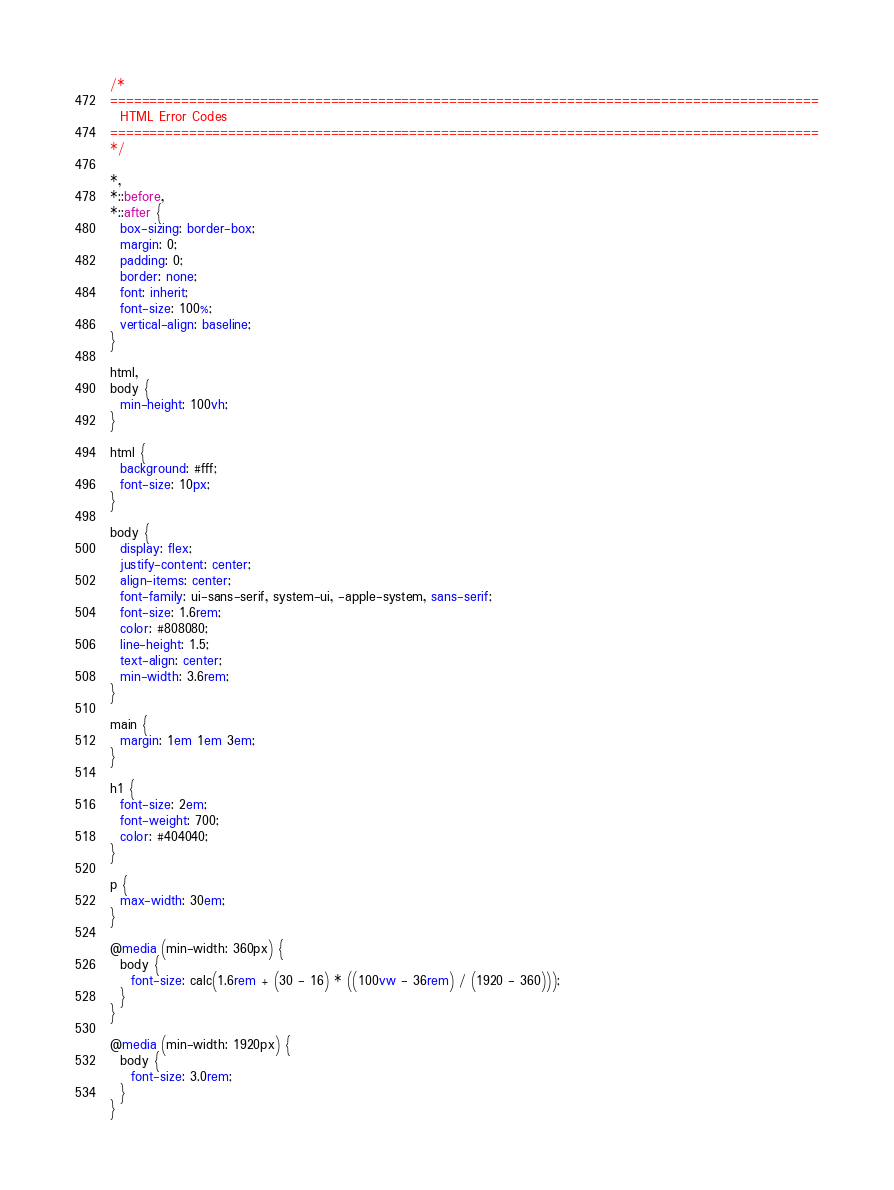<code> <loc_0><loc_0><loc_500><loc_500><_CSS_>/*
==========================================================================================
  HTML Error Codes
==========================================================================================
*/

*,
*::before,
*::after {
  box-sizing: border-box;
  margin: 0;
  padding: 0;
  border: none;
  font: inherit;
  font-size: 100%;
  vertical-align: baseline;
}

html,
body {
  min-height: 100vh;
}

html {
  background: #fff;
  font-size: 10px;
}

body {
  display: flex;
  justify-content: center;
  align-items: center;
  font-family: ui-sans-serif, system-ui, -apple-system, sans-serif;
  font-size: 1.6rem;
  color: #808080;
  line-height: 1.5;
  text-align: center;
  min-width: 3.6rem;
}

main {
  margin: 1em 1em 3em;
}

h1 {
  font-size: 2em;
  font-weight: 700;
  color: #404040;
}

p {
  max-width: 30em;
}

@media (min-width: 360px) {
  body {
    font-size: calc(1.6rem + (30 - 16) * ((100vw - 36rem) / (1920 - 360)));
  }
}

@media (min-width: 1920px) {
  body {
    font-size: 3.0rem;
  }
}
</code> 